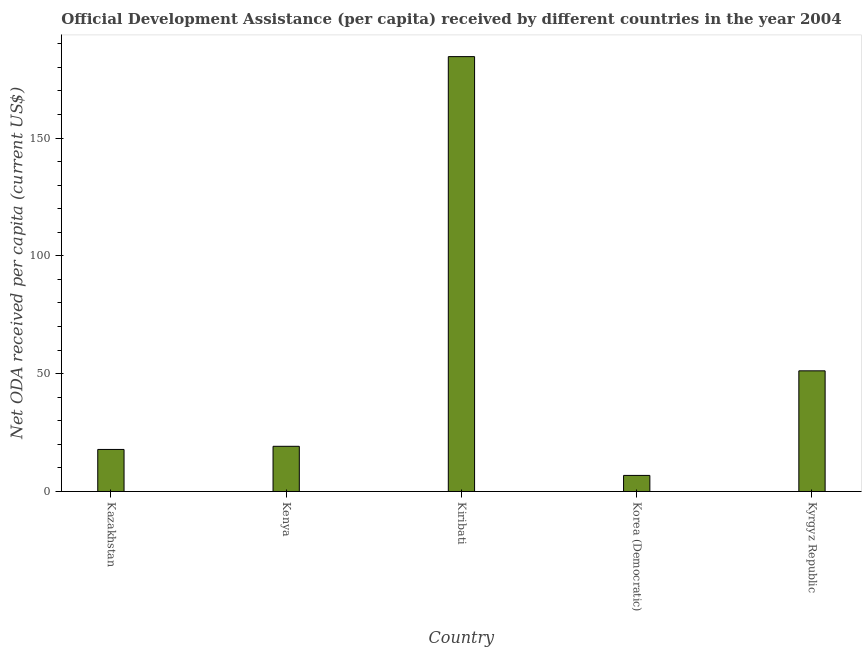What is the title of the graph?
Ensure brevity in your answer.  Official Development Assistance (per capita) received by different countries in the year 2004. What is the label or title of the Y-axis?
Offer a terse response. Net ODA received per capita (current US$). What is the net oda received per capita in Kiribati?
Your response must be concise. 184.55. Across all countries, what is the maximum net oda received per capita?
Offer a very short reply. 184.55. Across all countries, what is the minimum net oda received per capita?
Make the answer very short. 6.82. In which country was the net oda received per capita maximum?
Your answer should be very brief. Kiribati. In which country was the net oda received per capita minimum?
Your response must be concise. Korea (Democratic). What is the sum of the net oda received per capita?
Offer a terse response. 279.57. What is the difference between the net oda received per capita in Kazakhstan and Kenya?
Your answer should be compact. -1.34. What is the average net oda received per capita per country?
Provide a short and direct response. 55.91. What is the median net oda received per capita?
Offer a very short reply. 19.17. In how many countries, is the net oda received per capita greater than 30 US$?
Your answer should be compact. 2. Is the difference between the net oda received per capita in Korea (Democratic) and Kyrgyz Republic greater than the difference between any two countries?
Provide a succinct answer. No. What is the difference between the highest and the second highest net oda received per capita?
Your answer should be very brief. 133.35. What is the difference between the highest and the lowest net oda received per capita?
Your response must be concise. 177.73. How many bars are there?
Provide a succinct answer. 5. Are all the bars in the graph horizontal?
Keep it short and to the point. No. How many countries are there in the graph?
Your answer should be very brief. 5. Are the values on the major ticks of Y-axis written in scientific E-notation?
Your response must be concise. No. What is the Net ODA received per capita (current US$) of Kazakhstan?
Keep it short and to the point. 17.84. What is the Net ODA received per capita (current US$) of Kenya?
Provide a succinct answer. 19.17. What is the Net ODA received per capita (current US$) of Kiribati?
Your response must be concise. 184.55. What is the Net ODA received per capita (current US$) in Korea (Democratic)?
Make the answer very short. 6.82. What is the Net ODA received per capita (current US$) of Kyrgyz Republic?
Ensure brevity in your answer.  51.2. What is the difference between the Net ODA received per capita (current US$) in Kazakhstan and Kenya?
Provide a succinct answer. -1.34. What is the difference between the Net ODA received per capita (current US$) in Kazakhstan and Kiribati?
Provide a succinct answer. -166.71. What is the difference between the Net ODA received per capita (current US$) in Kazakhstan and Korea (Democratic)?
Make the answer very short. 11.02. What is the difference between the Net ODA received per capita (current US$) in Kazakhstan and Kyrgyz Republic?
Your answer should be compact. -33.37. What is the difference between the Net ODA received per capita (current US$) in Kenya and Kiribati?
Provide a short and direct response. -165.38. What is the difference between the Net ODA received per capita (current US$) in Kenya and Korea (Democratic)?
Your response must be concise. 12.36. What is the difference between the Net ODA received per capita (current US$) in Kenya and Kyrgyz Republic?
Your answer should be compact. -32.03. What is the difference between the Net ODA received per capita (current US$) in Kiribati and Korea (Democratic)?
Make the answer very short. 177.73. What is the difference between the Net ODA received per capita (current US$) in Kiribati and Kyrgyz Republic?
Your response must be concise. 133.35. What is the difference between the Net ODA received per capita (current US$) in Korea (Democratic) and Kyrgyz Republic?
Your answer should be compact. -44.39. What is the ratio of the Net ODA received per capita (current US$) in Kazakhstan to that in Kiribati?
Offer a very short reply. 0.1. What is the ratio of the Net ODA received per capita (current US$) in Kazakhstan to that in Korea (Democratic)?
Your response must be concise. 2.62. What is the ratio of the Net ODA received per capita (current US$) in Kazakhstan to that in Kyrgyz Republic?
Give a very brief answer. 0.35. What is the ratio of the Net ODA received per capita (current US$) in Kenya to that in Kiribati?
Your response must be concise. 0.1. What is the ratio of the Net ODA received per capita (current US$) in Kenya to that in Korea (Democratic)?
Your answer should be compact. 2.81. What is the ratio of the Net ODA received per capita (current US$) in Kenya to that in Kyrgyz Republic?
Give a very brief answer. 0.37. What is the ratio of the Net ODA received per capita (current US$) in Kiribati to that in Korea (Democratic)?
Ensure brevity in your answer.  27.07. What is the ratio of the Net ODA received per capita (current US$) in Kiribati to that in Kyrgyz Republic?
Provide a short and direct response. 3.6. What is the ratio of the Net ODA received per capita (current US$) in Korea (Democratic) to that in Kyrgyz Republic?
Your answer should be compact. 0.13. 